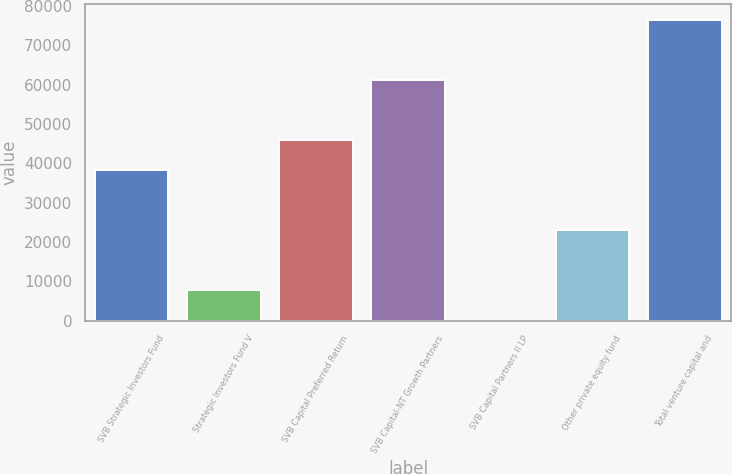<chart> <loc_0><loc_0><loc_500><loc_500><bar_chart><fcel>SVB Strategic Investors Fund<fcel>Strategic Investors Fund V<fcel>SVB Capital Preferred Return<fcel>SVB Capital-NT Growth Partners<fcel>SVB Capital Partners II LP<fcel>Other private equity fund<fcel>Total venture capital and<nl><fcel>38270.5<fcel>7682.9<fcel>45917.4<fcel>61211.2<fcel>36<fcel>22976.7<fcel>76505<nl></chart> 